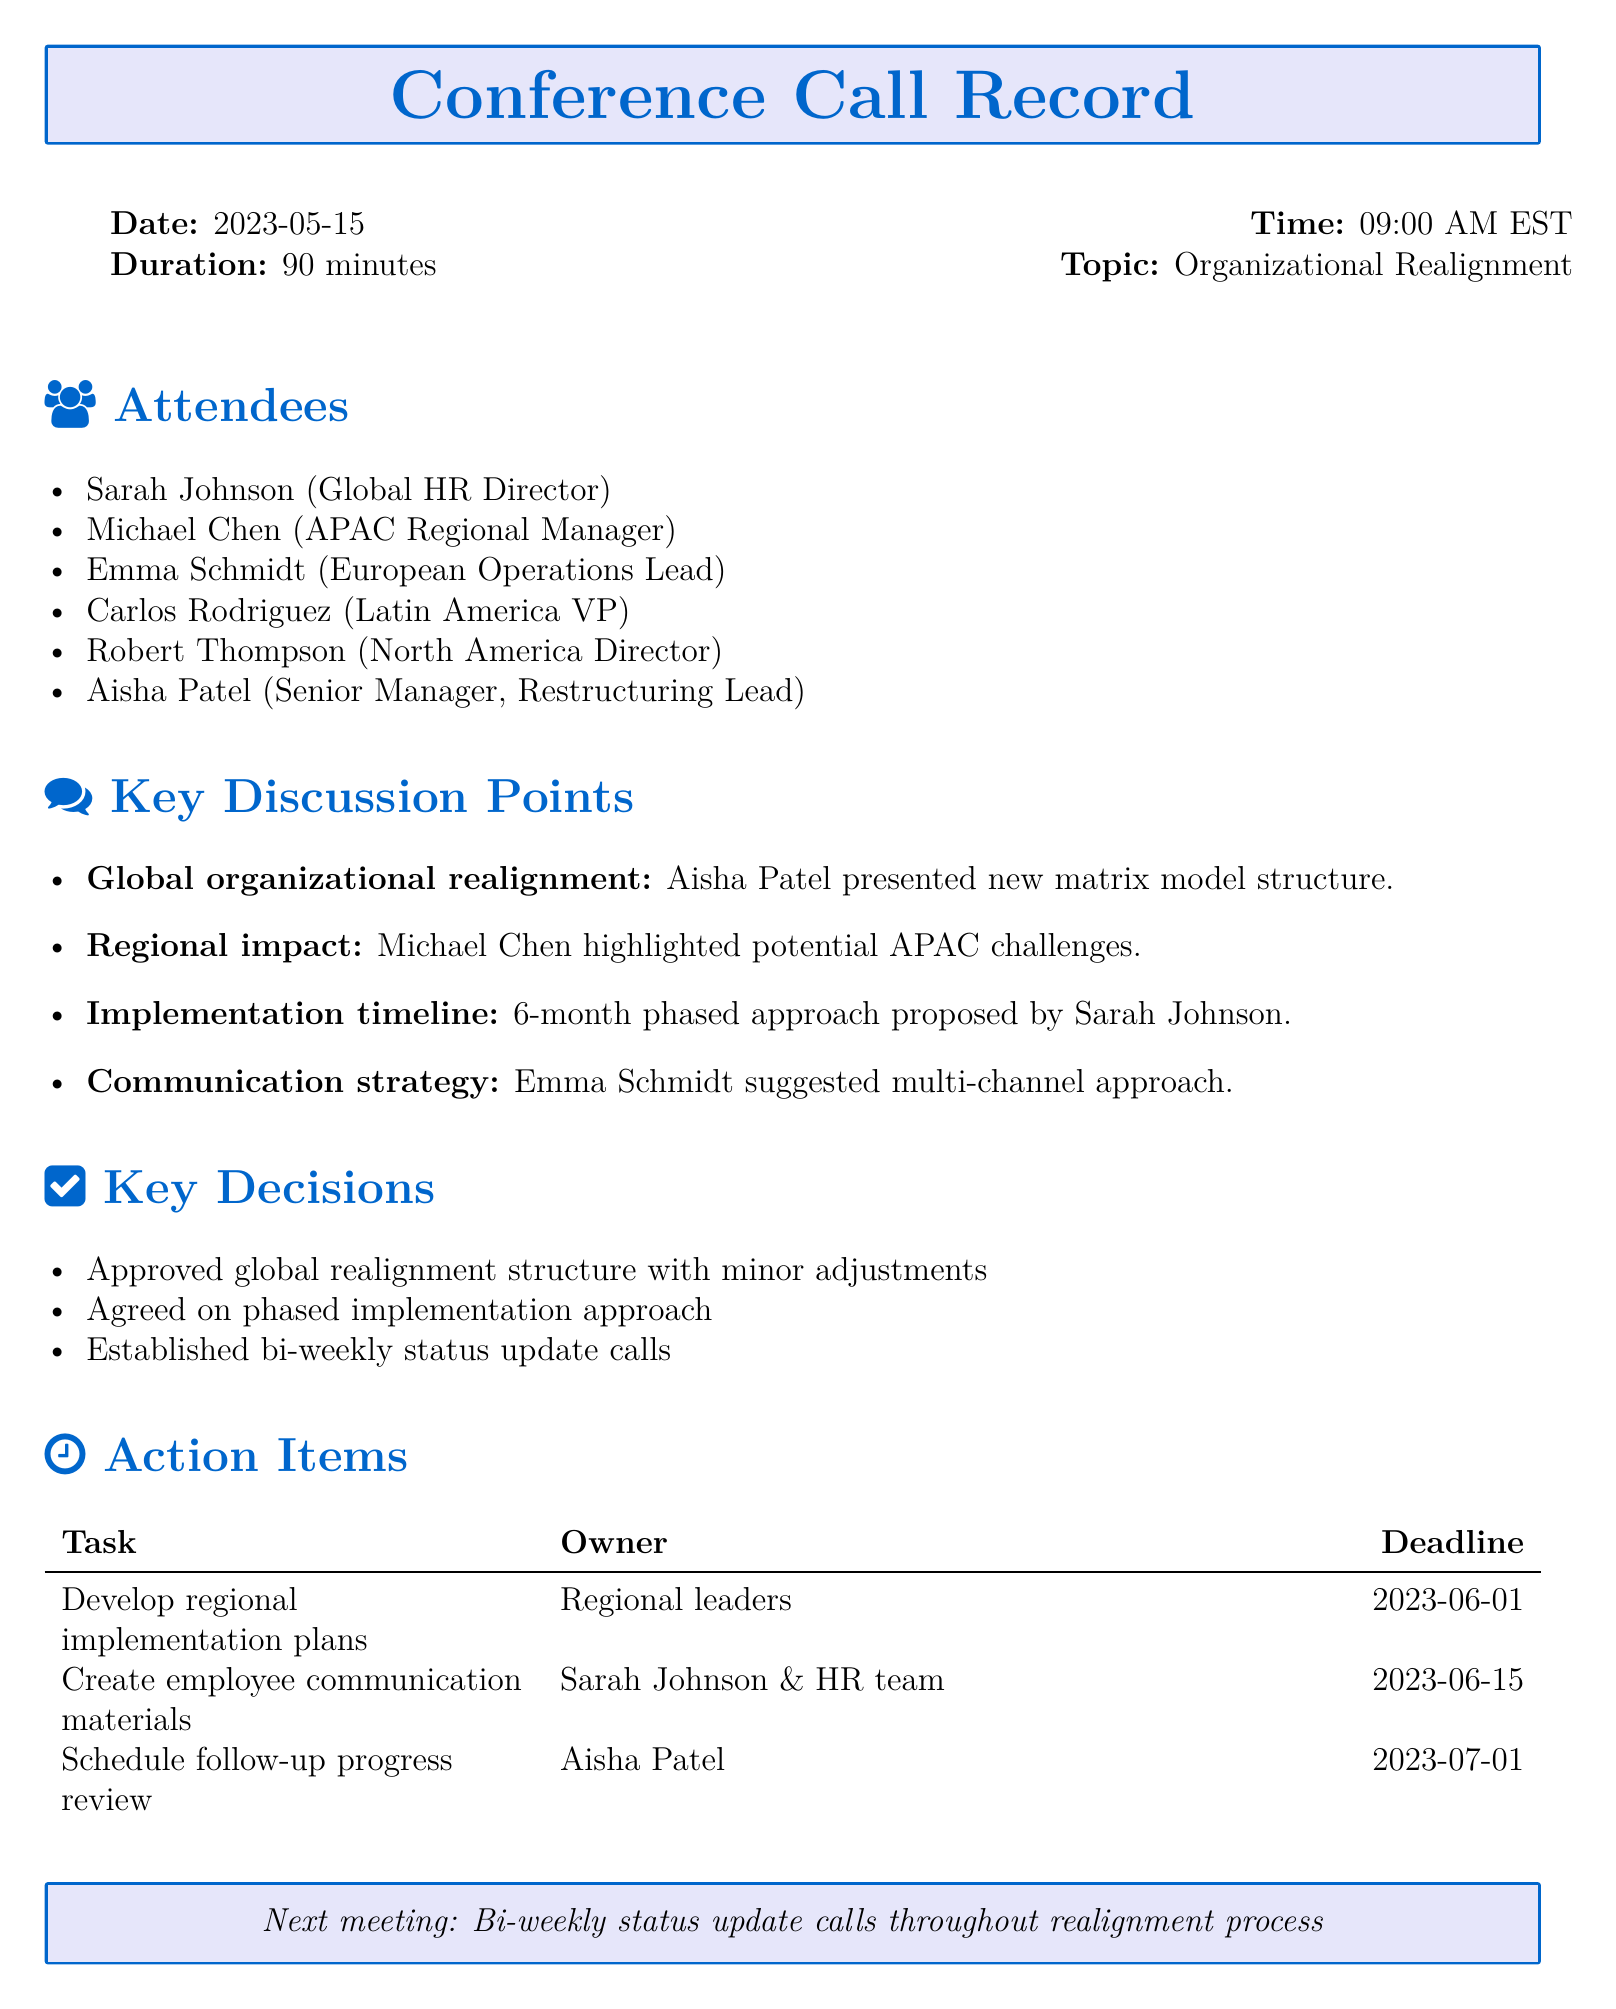What was the date of the conference call? The date of the conference call is specified in the document as May 15, 2023.
Answer: May 15, 2023 Who presented the new matrix model structure? The document indicates that Aisha Patel presented the new matrix model structure.
Answer: Aisha Patel What is the proposed implementation timeline? The implementation timeline is noted as a 6-month phased approach in the document.
Answer: 6-month phased approach Which attendee suggested a multi-channel communication strategy? According to the document, Emma Schmidt suggested the multi-channel communication strategy.
Answer: Emma Schmidt What is the deadline for developing regional implementation plans? The document mentions that the deadline for developing regional implementation plans is June 1, 2023.
Answer: June 1, 2023 How often will the status update calls occur during the realignment process? The document states that bi-weekly status update calls will occur throughout the realignment process.
Answer: Bi-weekly What was approved during the meeting? The document states that the global realignment structure was approved with minor adjustments.
Answer: Global realignment structure Who is responsible for creating employee communication materials? Sarah Johnson and the HR team are responsible for creating employee communication materials as indicated in the document.
Answer: Sarah Johnson & HR team What was highlighted as a potential challenge in APAC? The potential challenges in APAC were highlighted by Michael Chen during the call.
Answer: Michael Chen 